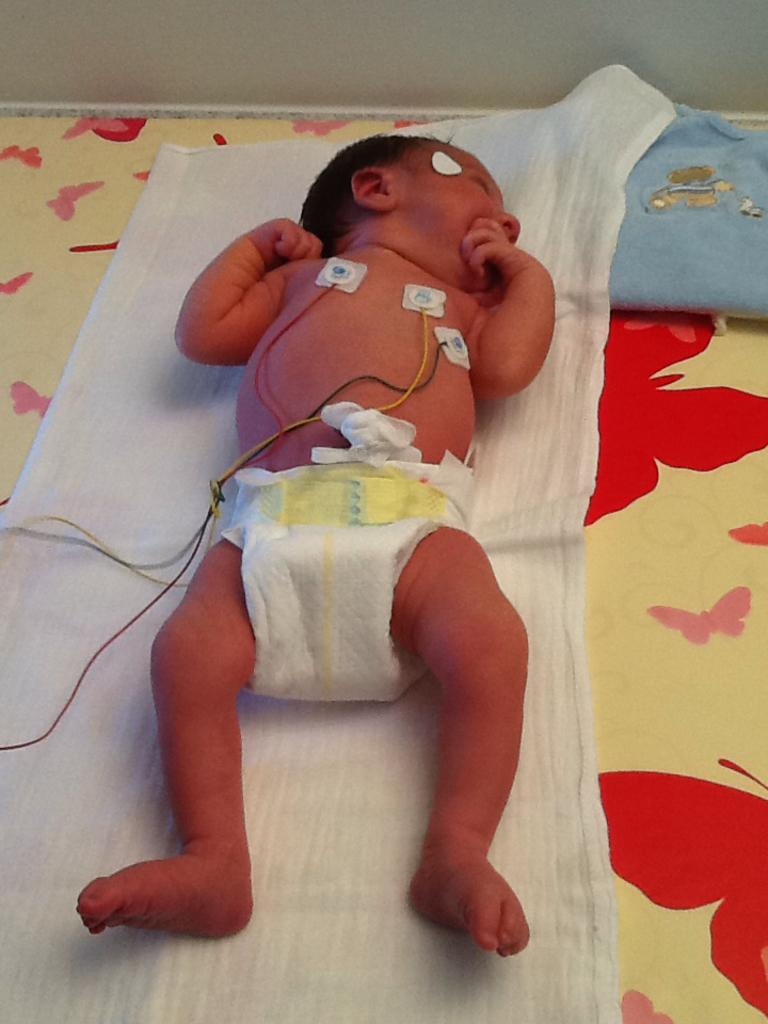What is the main subject of the image? There is a baby in the image. Where is the baby located? The baby is on a bed. What else can be seen in the image besides the baby? There are cables visible in the image. What type of garden can be seen in the image? There is no garden present in the image; it features a baby on a bed with visible cables. 